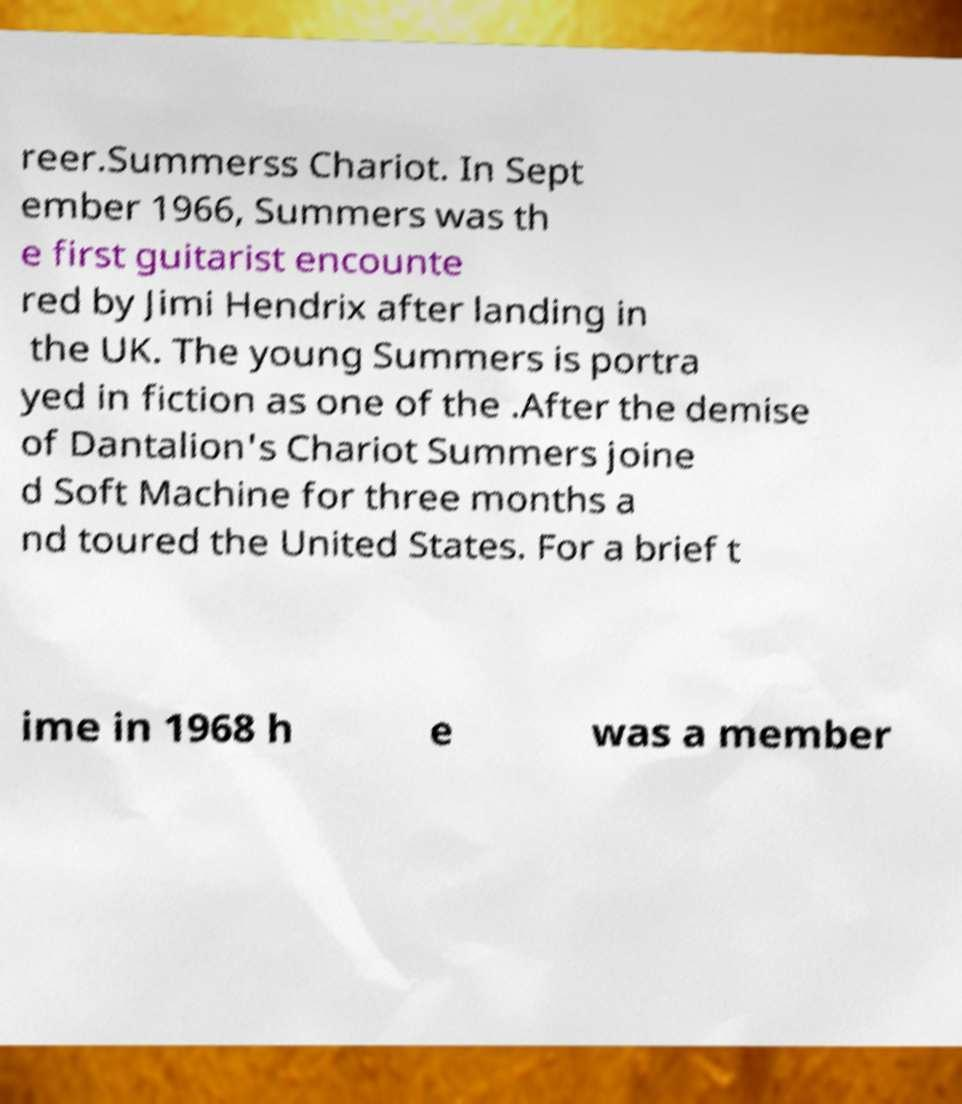Please read and relay the text visible in this image. What does it say? reer.Summerss Chariot. In Sept ember 1966, Summers was th e first guitarist encounte red by Jimi Hendrix after landing in the UK. The young Summers is portra yed in fiction as one of the .After the demise of Dantalion's Chariot Summers joine d Soft Machine for three months a nd toured the United States. For a brief t ime in 1968 h e was a member 